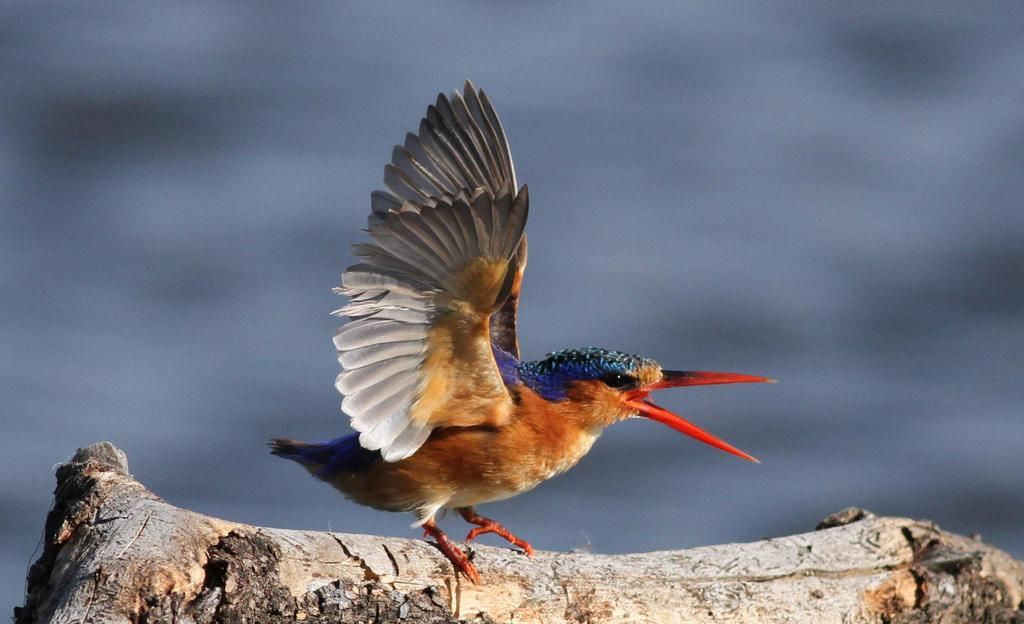What type of animal can be seen in the picture? There is a bird in the picture. Can you describe the bird's appearance? The bird is colorful. What is the bird standing on in the picture? The bird is on a wooden object. How would you describe the background of the image? The background is blurred. What type of copper material can be seen in the picture? There is no copper material present in the image. What type of vacation is the bird taking in the picture? The image does not depict a vacation, and the bird's activities are not related to a vacation. 